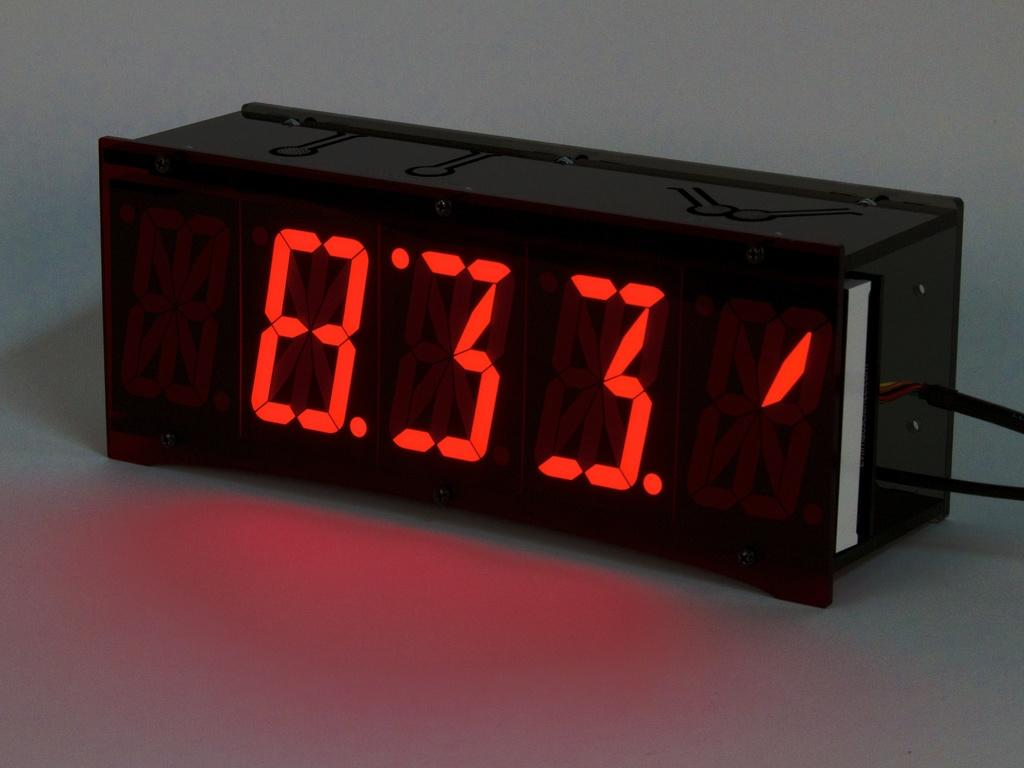Provide a one-sentence caption for the provided image. A black digital clock reads 8:33 in red. 